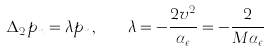Convert formula to latex. <formula><loc_0><loc_0><loc_500><loc_500>\Delta _ { 2 } p _ { n } = \lambda p _ { n } , \quad \lambda = - \frac { 2 v ^ { 2 } } { \alpha _ { \epsilon } } = - \frac { 2 } { M \alpha _ { \epsilon } }</formula> 